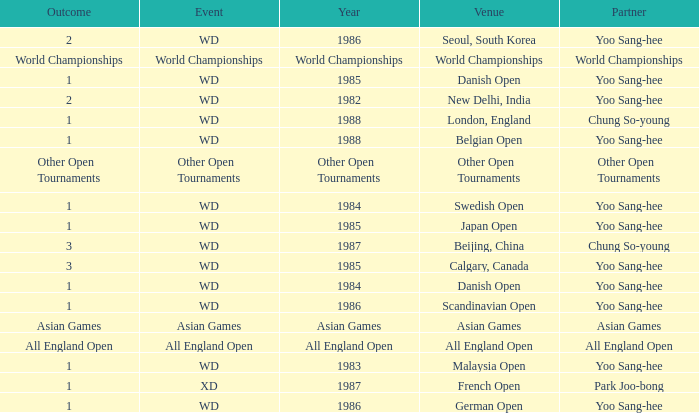What is the Partner during the Asian Games Year? Asian Games. 